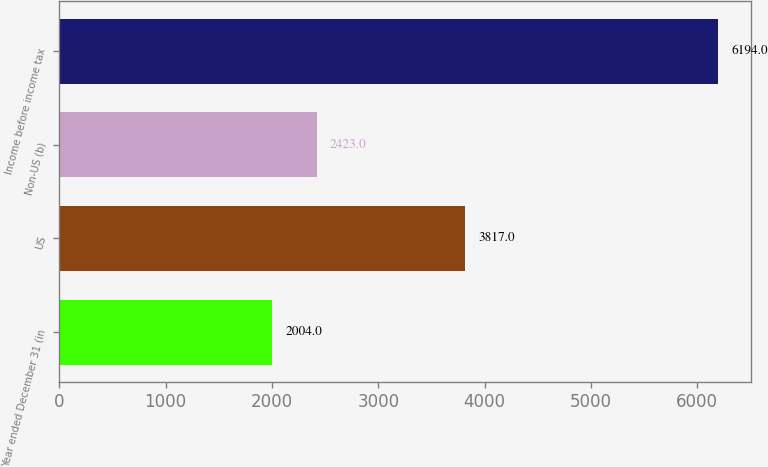<chart> <loc_0><loc_0><loc_500><loc_500><bar_chart><fcel>Year ended December 31 (in<fcel>US<fcel>Non-US (b)<fcel>Income before income tax<nl><fcel>2004<fcel>3817<fcel>2423<fcel>6194<nl></chart> 